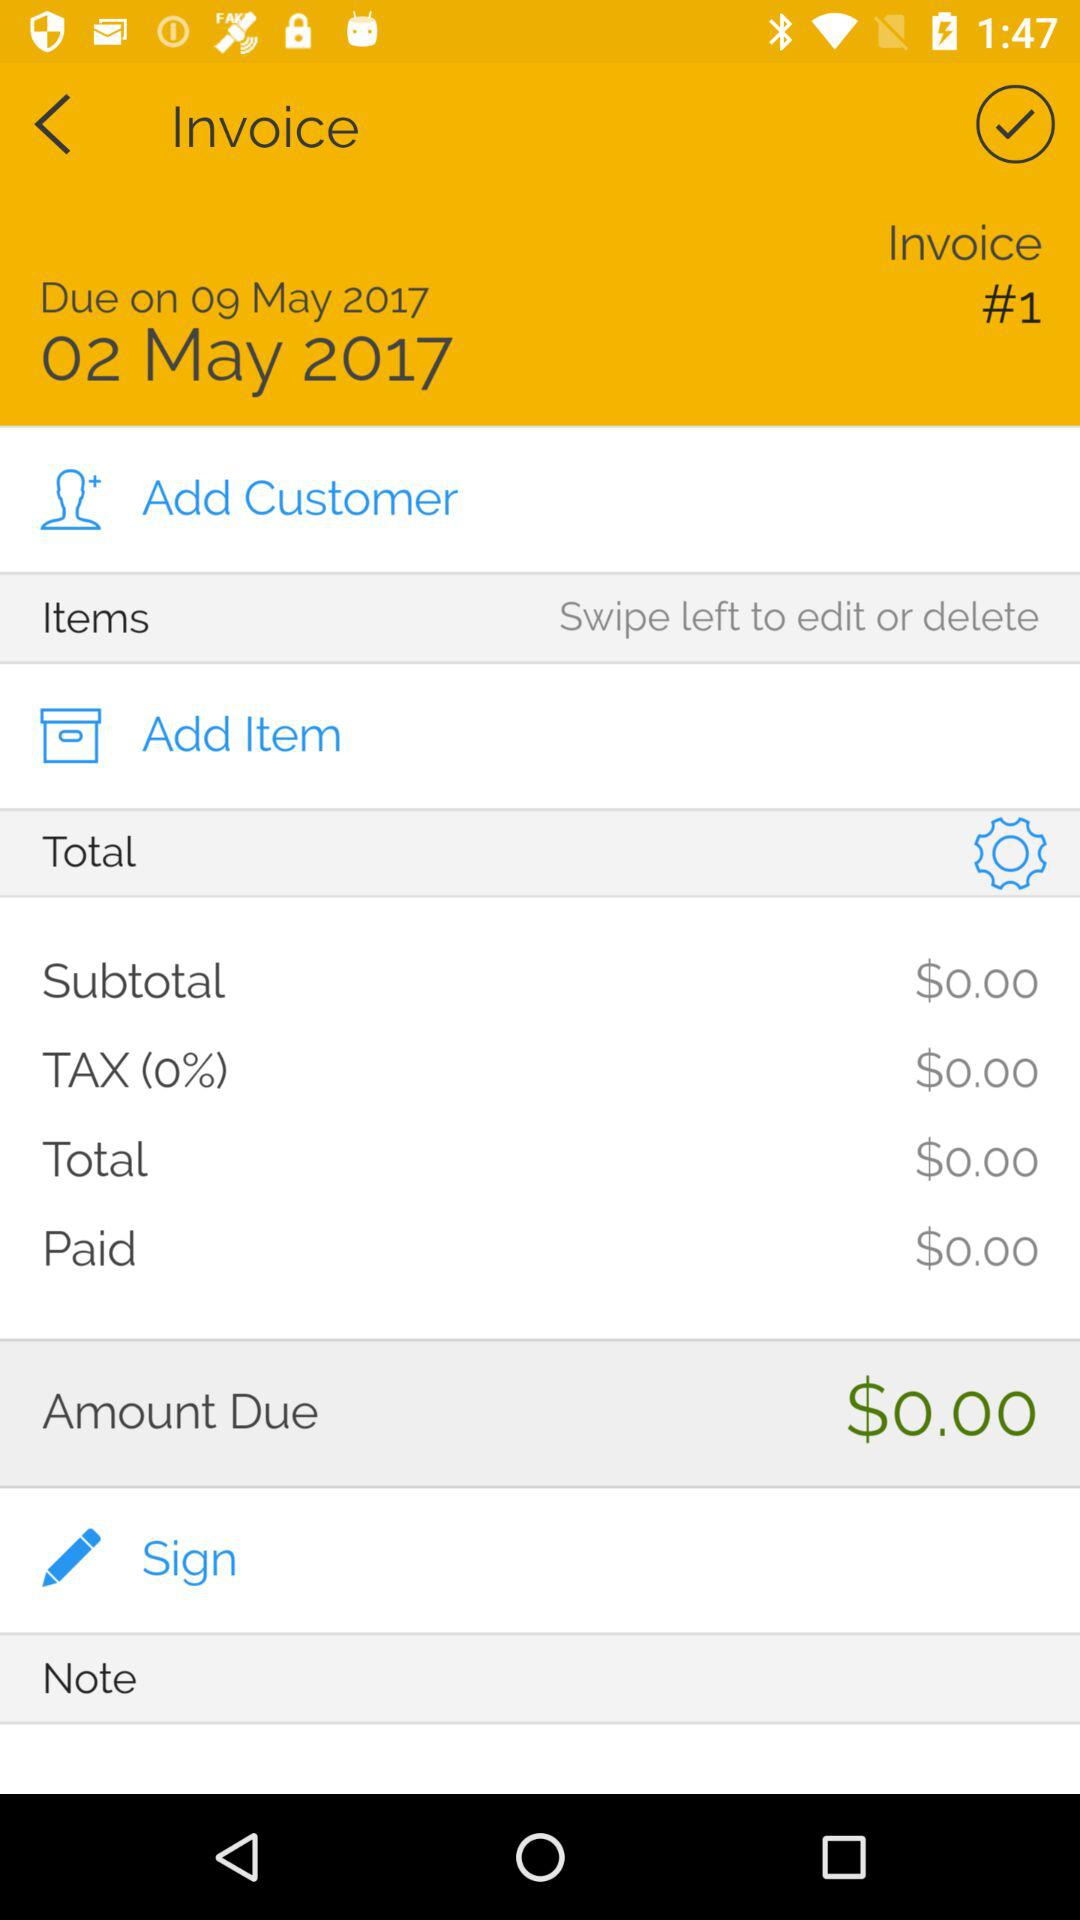What's the due date of the invoice? The due date of the invoice is May 9, 2017. 